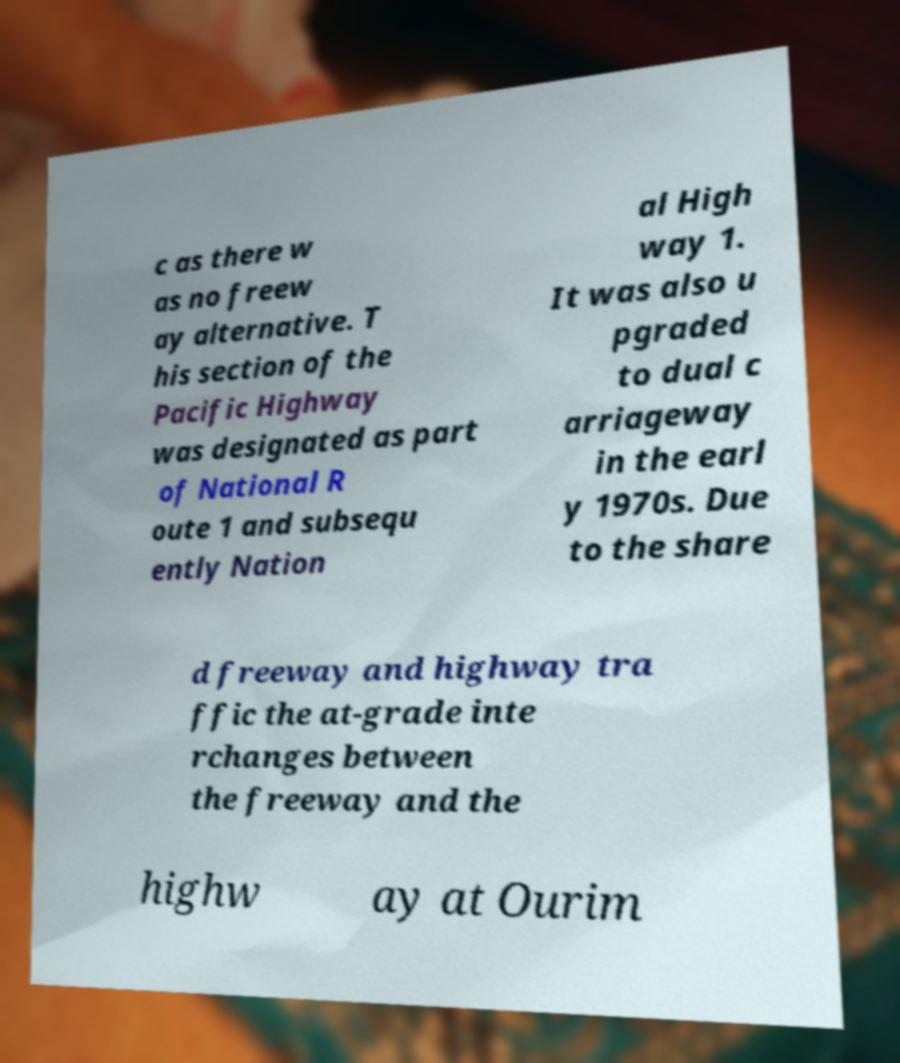What messages or text are displayed in this image? I need them in a readable, typed format. c as there w as no freew ay alternative. T his section of the Pacific Highway was designated as part of National R oute 1 and subsequ ently Nation al High way 1. It was also u pgraded to dual c arriageway in the earl y 1970s. Due to the share d freeway and highway tra ffic the at-grade inte rchanges between the freeway and the highw ay at Ourim 